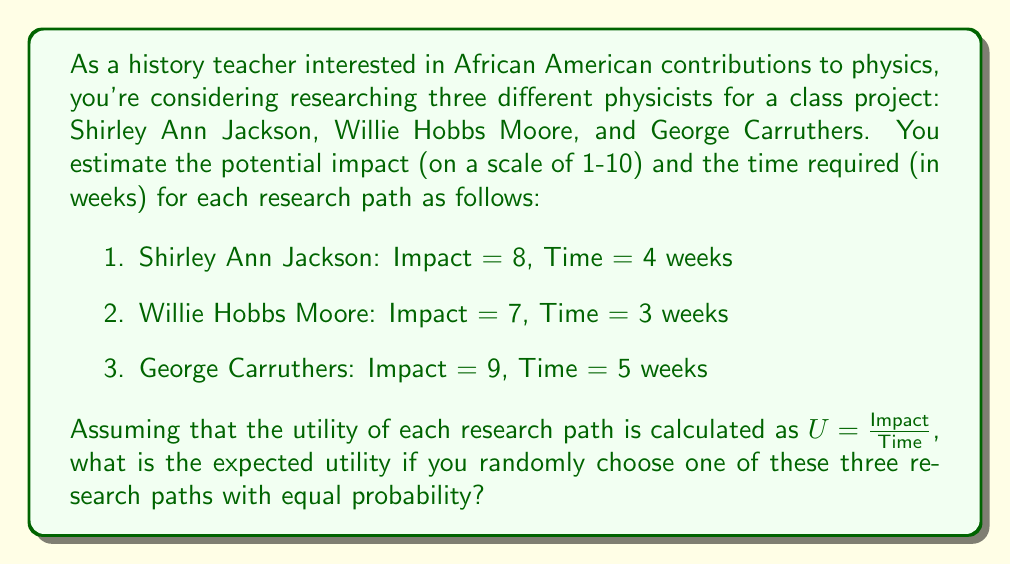Teach me how to tackle this problem. To solve this problem, we need to follow these steps:

1. Calculate the utility for each research path.
2. Find the probability of choosing each path.
3. Calculate the expected utility using the formula for expected value.

Step 1: Calculate the utility for each research path

The utility is given by the formula $U = \frac{Impact}{Time}$

For Shirley Ann Jackson: 
$U_1 = \frac{8}{4} = 2$

For Willie Hobbs Moore:
$U_2 = \frac{7}{3} \approx 2.33$

For George Carruthers:
$U_3 = \frac{9}{5} = 1.8$

Step 2: Find the probability of choosing each path

Since we're randomly choosing one of the three paths with equal probability, the probability of choosing each path is $\frac{1}{3}$.

Step 3: Calculate the expected utility

The expected utility is given by the formula:

$E(U) = \sum_{i=1}^n p_i U_i$

Where $p_i$ is the probability of choosing path $i$, and $U_i$ is the utility of path $i$.

Substituting our values:

$E(U) = \frac{1}{3} \cdot 2 + \frac{1}{3} \cdot 2.33 + \frac{1}{3} \cdot 1.8$

$E(U) = \frac{2 + 2.33 + 1.8}{3}$

$E(U) = \frac{6.13}{3}$

$E(U) \approx 2.04$
Answer: The expected utility of randomly choosing one of the three research paths is approximately 2.04. 